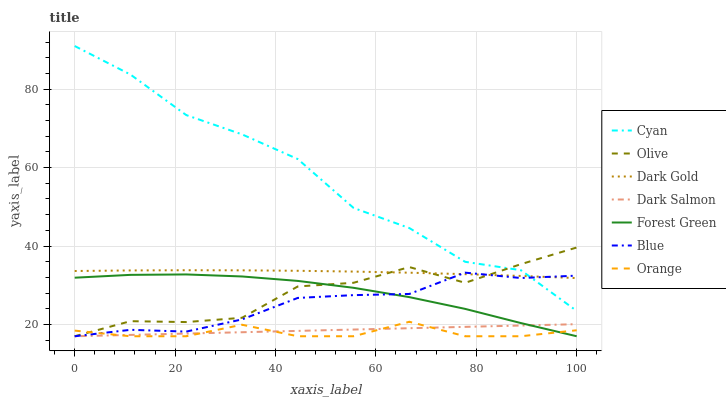Does Orange have the minimum area under the curve?
Answer yes or no. Yes. Does Cyan have the maximum area under the curve?
Answer yes or no. Yes. Does Dark Gold have the minimum area under the curve?
Answer yes or no. No. Does Dark Gold have the maximum area under the curve?
Answer yes or no. No. Is Dark Salmon the smoothest?
Answer yes or no. Yes. Is Cyan the roughest?
Answer yes or no. Yes. Is Dark Gold the smoothest?
Answer yes or no. No. Is Dark Gold the roughest?
Answer yes or no. No. Does Blue have the lowest value?
Answer yes or no. Yes. Does Dark Gold have the lowest value?
Answer yes or no. No. Does Cyan have the highest value?
Answer yes or no. Yes. Does Dark Gold have the highest value?
Answer yes or no. No. Is Forest Green less than Cyan?
Answer yes or no. Yes. Is Dark Gold greater than Dark Salmon?
Answer yes or no. Yes. Does Blue intersect Dark Salmon?
Answer yes or no. Yes. Is Blue less than Dark Salmon?
Answer yes or no. No. Is Blue greater than Dark Salmon?
Answer yes or no. No. Does Forest Green intersect Cyan?
Answer yes or no. No. 